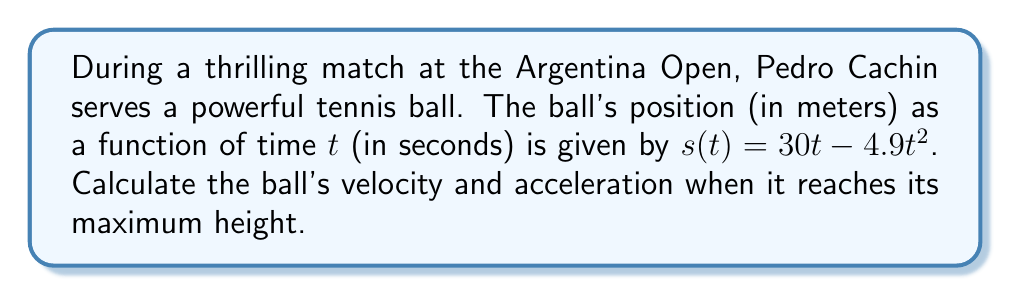Could you help me with this problem? Let's approach this step-by-step:

1) To find the velocity function, we need to differentiate the position function:
   $$v(t) = \frac{ds}{dt} = 30 - 9.8t$$

2) To find the acceleration function, we differentiate the velocity function:
   $$a(t) = \frac{dv}{dt} = -9.8$$

3) The ball reaches its maximum height when the velocity is zero. So, let's find when $v(t) = 0$:
   $$0 = 30 - 9.8t$$
   $$9.8t = 30$$
   $$t = \frac{30}{9.8} \approx 3.06 \text{ seconds}$$

4) Now, let's calculate the velocity at this time:
   $$v(3.06) = 30 - 9.8(3.06) = 0 \text{ m/s}$$

5) The acceleration is constant throughout the motion:
   $$a = -9.8 \text{ m/s}^2$$

Therefore, at the maximum height:
- Velocity: 0 m/s
- Acceleration: -9.8 m/s²
Answer: Velocity: 0 m/s, Acceleration: -9.8 m/s² 